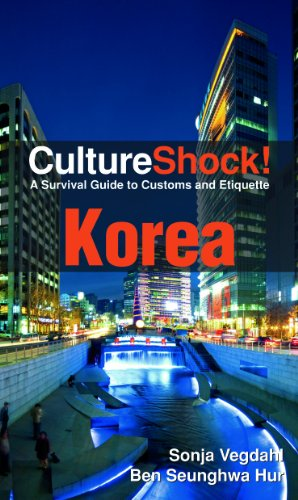Who wrote this book? The book 'CultureShock! Korea: A Survival Guide to Customs and Etiquette' is co-authored by Sonja Vegdahl and Ben Seunghwa Hur. 